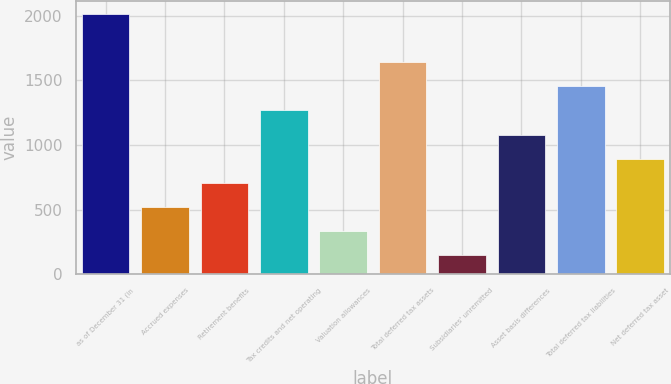Convert chart to OTSL. <chart><loc_0><loc_0><loc_500><loc_500><bar_chart><fcel>as of December 31 (in<fcel>Accrued expenses<fcel>Retirement benefits<fcel>Tax credits and net operating<fcel>Valuation allowances<fcel>Total deferred tax assets<fcel>Subsidiaries' unremitted<fcel>Asset basis differences<fcel>Total deferred tax liabilities<fcel>Net deferred tax asset<nl><fcel>2016<fcel>519.2<fcel>706.3<fcel>1267.6<fcel>332.1<fcel>1641.8<fcel>145<fcel>1080.5<fcel>1454.7<fcel>893.4<nl></chart> 